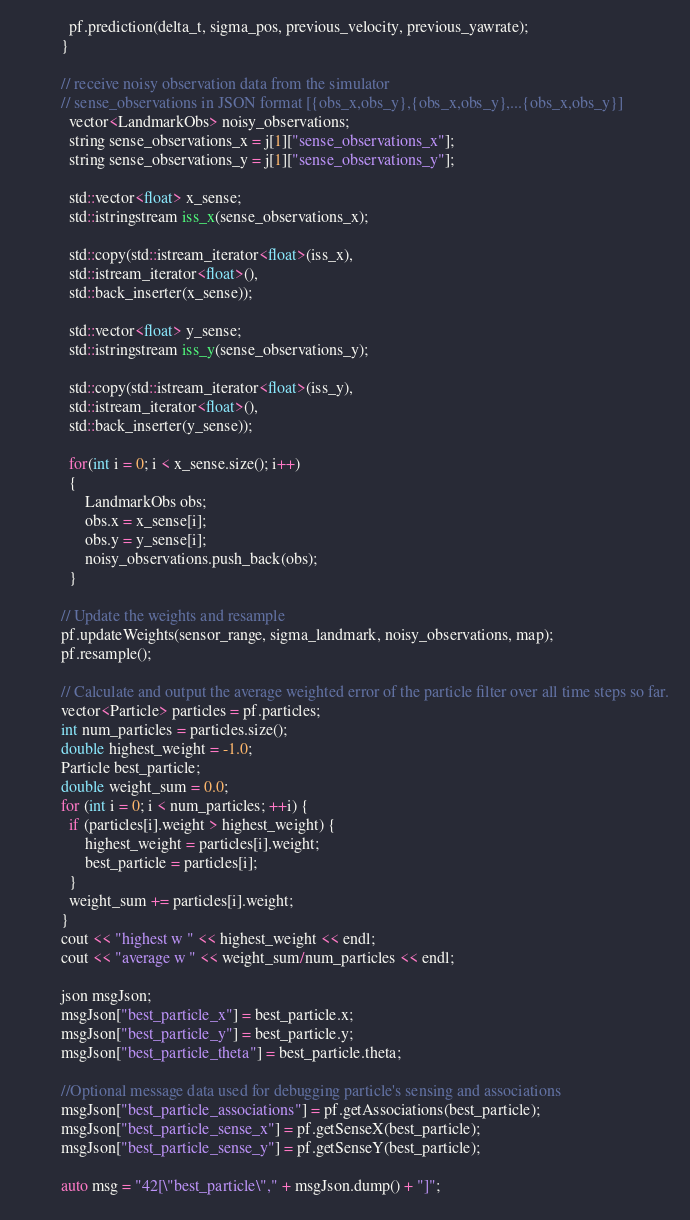<code> <loc_0><loc_0><loc_500><loc_500><_C++_>
			pf.prediction(delta_t, sigma_pos, previous_velocity, previous_yawrate);
		  }

		  // receive noisy observation data from the simulator
		  // sense_observations in JSON format [{obs_x,obs_y},{obs_x,obs_y},...{obs_x,obs_y}]
		  	vector<LandmarkObs> noisy_observations;
		  	string sense_observations_x = j[1]["sense_observations_x"];
		  	string sense_observations_y = j[1]["sense_observations_y"];

		  	std::vector<float> x_sense;
  			std::istringstream iss_x(sense_observations_x);

  			std::copy(std::istream_iterator<float>(iss_x),
        	std::istream_iterator<float>(),
        	std::back_inserter(x_sense));

        	std::vector<float> y_sense;
  			std::istringstream iss_y(sense_observations_y);

  			std::copy(std::istream_iterator<float>(iss_y),
        	std::istream_iterator<float>(),
        	std::back_inserter(y_sense));

        	for(int i = 0; i < x_sense.size(); i++)
        	{
        		LandmarkObs obs;
        		obs.x = x_sense[i];
				obs.y = y_sense[i];
				noisy_observations.push_back(obs);
        	}

		  // Update the weights and resample
		  pf.updateWeights(sensor_range, sigma_landmark, noisy_observations, map);
		  pf.resample();

		  // Calculate and output the average weighted error of the particle filter over all time steps so far.
		  vector<Particle> particles = pf.particles;
		  int num_particles = particles.size();
		  double highest_weight = -1.0;
		  Particle best_particle;
		  double weight_sum = 0.0;
		  for (int i = 0; i < num_particles; ++i) {
			if (particles[i].weight > highest_weight) {
				highest_weight = particles[i].weight;
				best_particle = particles[i];
			}
			weight_sum += particles[i].weight;
		  }
		  cout << "highest w " << highest_weight << endl;
		  cout << "average w " << weight_sum/num_particles << endl;

          json msgJson;
          msgJson["best_particle_x"] = best_particle.x;
          msgJson["best_particle_y"] = best_particle.y;
          msgJson["best_particle_theta"] = best_particle.theta;

          //Optional message data used for debugging particle's sensing and associations
          msgJson["best_particle_associations"] = pf.getAssociations(best_particle);
          msgJson["best_particle_sense_x"] = pf.getSenseX(best_particle);
          msgJson["best_particle_sense_y"] = pf.getSenseY(best_particle);

          auto msg = "42[\"best_particle\"," + msgJson.dump() + "]";</code> 